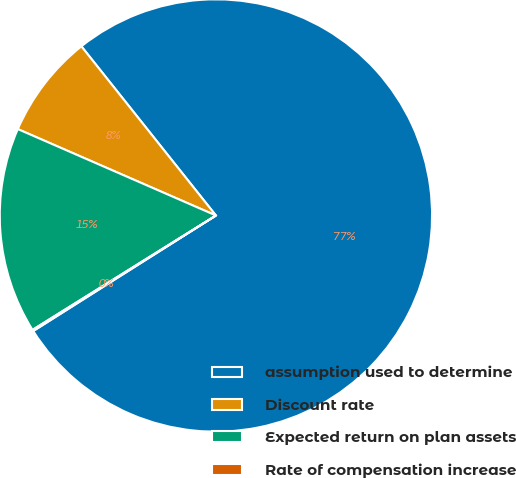<chart> <loc_0><loc_0><loc_500><loc_500><pie_chart><fcel>assumption used to determine<fcel>Discount rate<fcel>Expected return on plan assets<fcel>Rate of compensation increase<nl><fcel>76.71%<fcel>7.76%<fcel>15.42%<fcel>0.1%<nl></chart> 